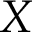Convert formula to latex. <formula><loc_0><loc_0><loc_500><loc_500>X</formula> 